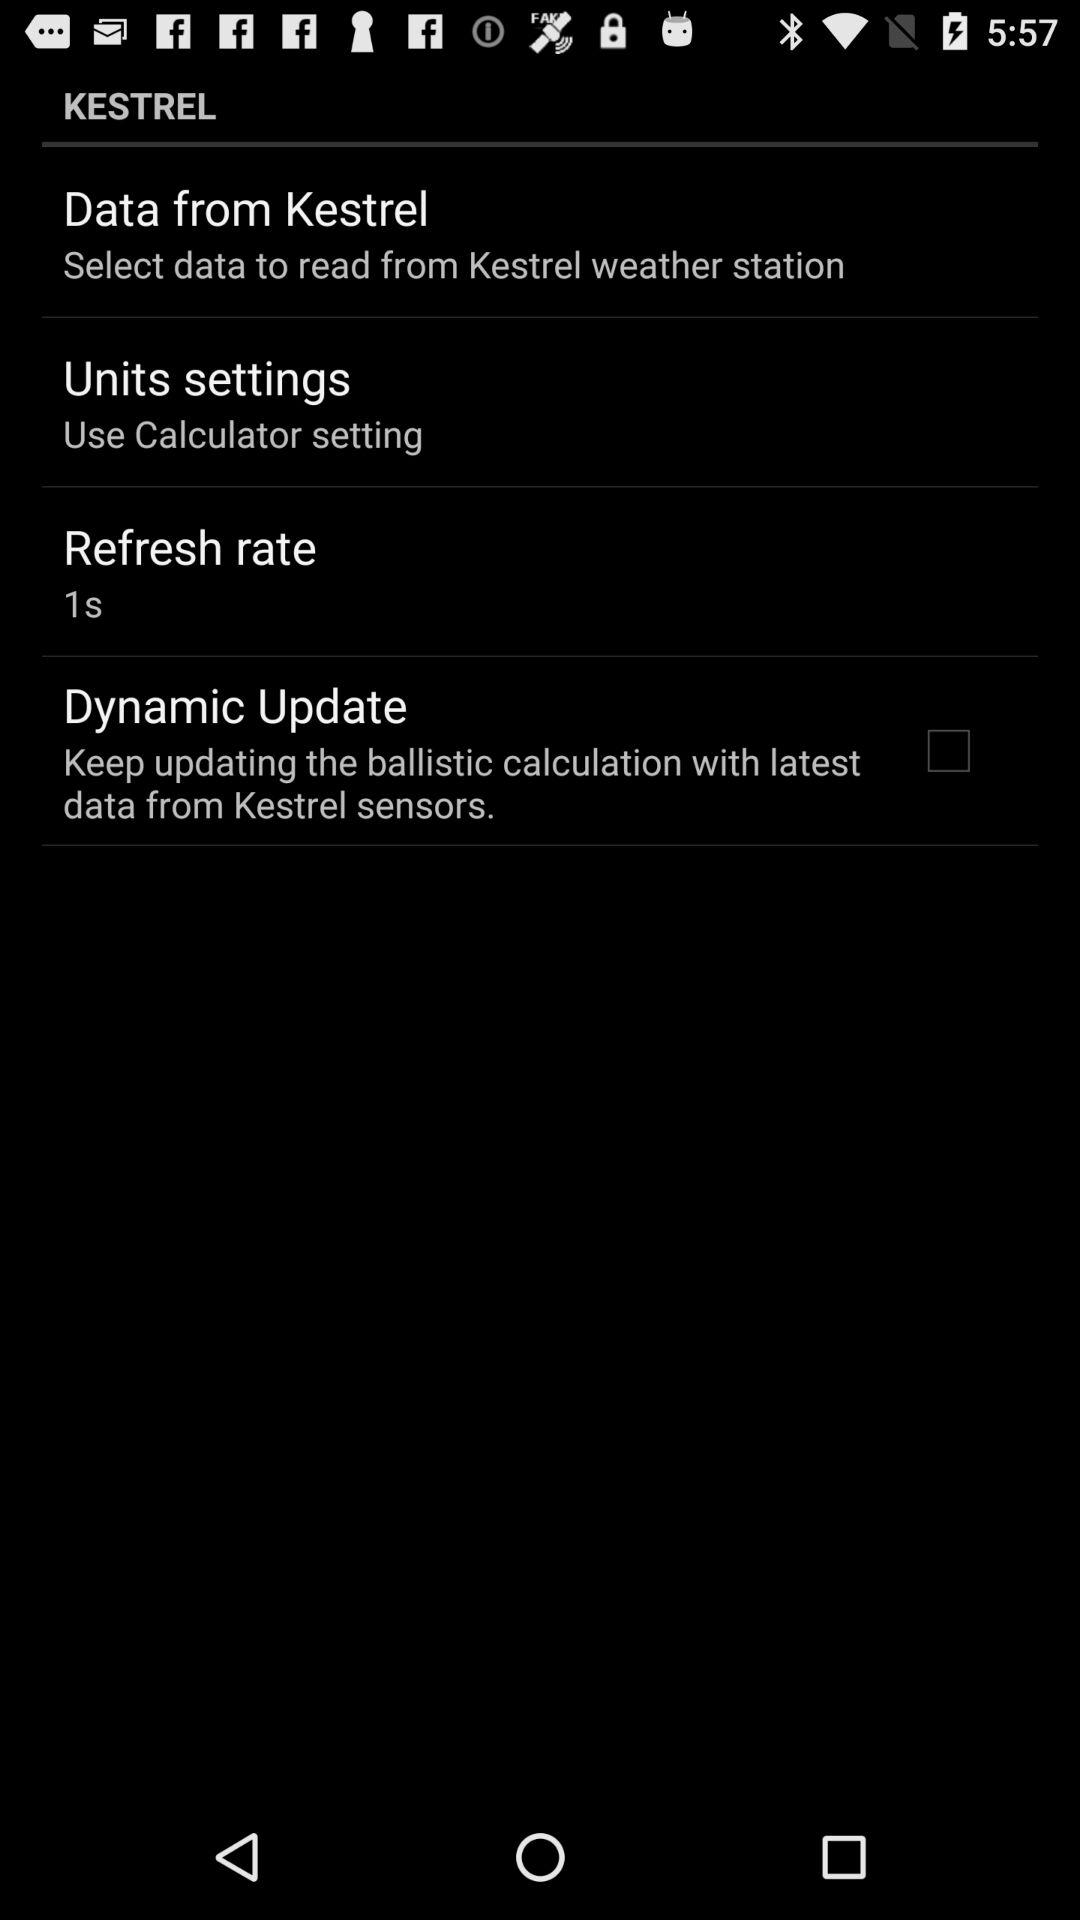Where is the weather station located?
When the provided information is insufficient, respond with <no answer>. <no answer> 